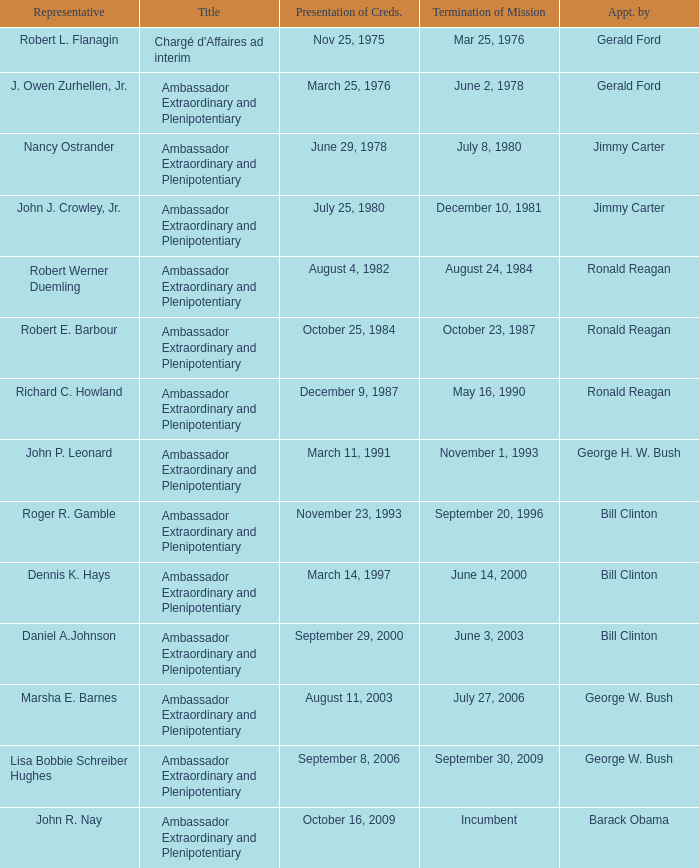Which representative was the Ambassador Extraordinary and Plenipotentiary and had a Termination of Mission date September 20, 1996? Roger R. Gamble. 